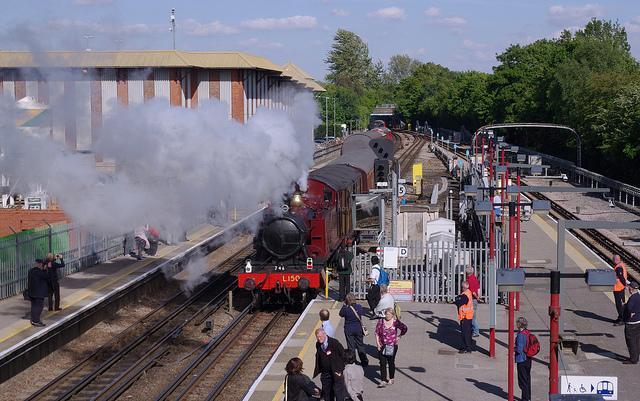How many buildings do you see?
Give a very brief answer. 1. How many bikes is there?
Give a very brief answer. 0. 